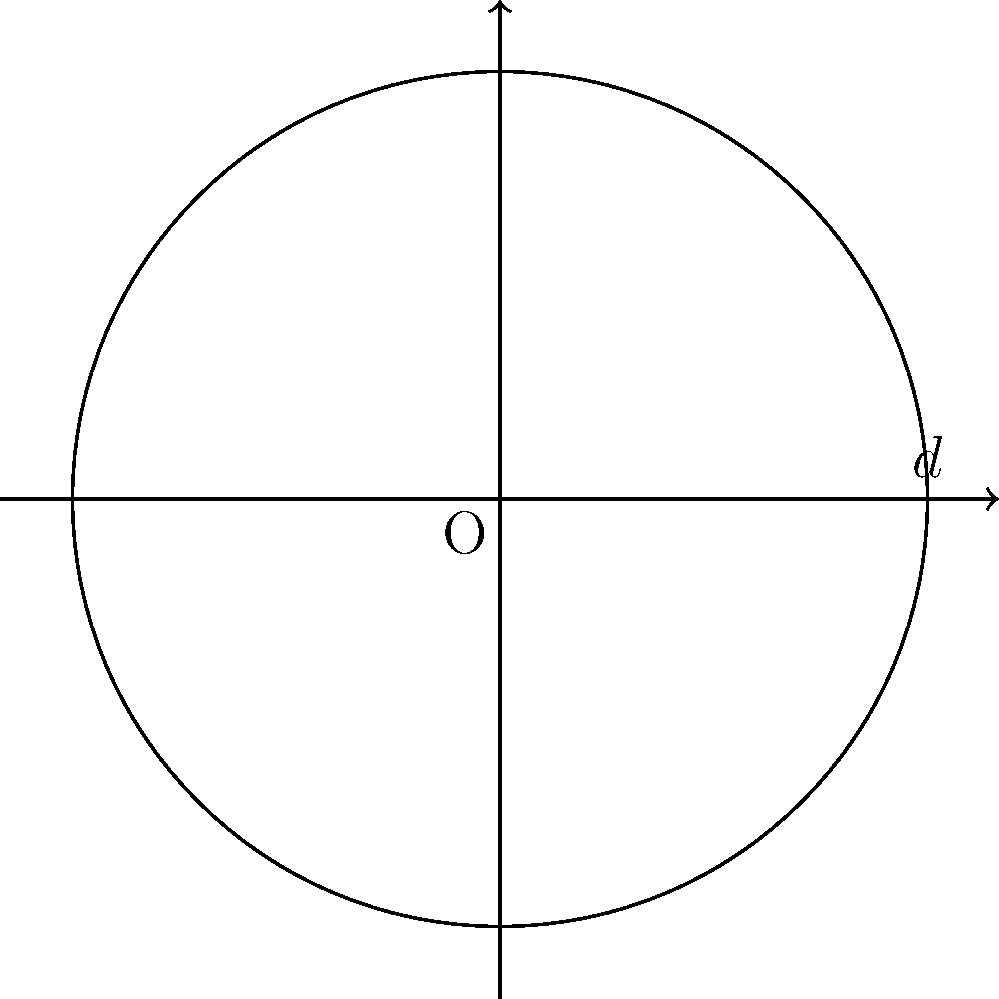As a medieval re-enactor, you're tasked with creating an authentic round table for a historical feast. The diameter of the table is measured to be 8 cubits. Using the approximation of π as 22/7 (a value known to medieval scholars), calculate the circumference of the table in cubits. To solve this problem, we'll follow these steps:

1) Recall the formula for the circumference of a circle:
   $C = \pi d$, where $C$ is the circumference, $\pi$ is pi, and $d$ is the diameter.

2) We're given that the diameter $d = 8$ cubits.

3) We're also told to use the approximation $\pi \approx \frac{22}{7}$.

4) Let's substitute these values into our formula:

   $C = \pi d = \frac{22}{7} \times 8$

5) Now we can calculate:
   
   $C = \frac{22 \times 8}{7} = \frac{176}{7} = 25\frac{1}{7}$

6) Therefore, the circumference of the table is $25\frac{1}{7}$ cubits.

This approximation method would have been familiar to medieval craftsmen and scholars, providing a reasonably accurate result for practical purposes.
Answer: $25\frac{1}{7}$ cubits 